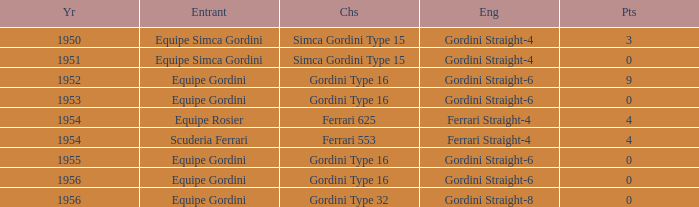Before 1956, what Chassis has Gordini Straight-4 engine with 3 points? Simca Gordini Type 15. 